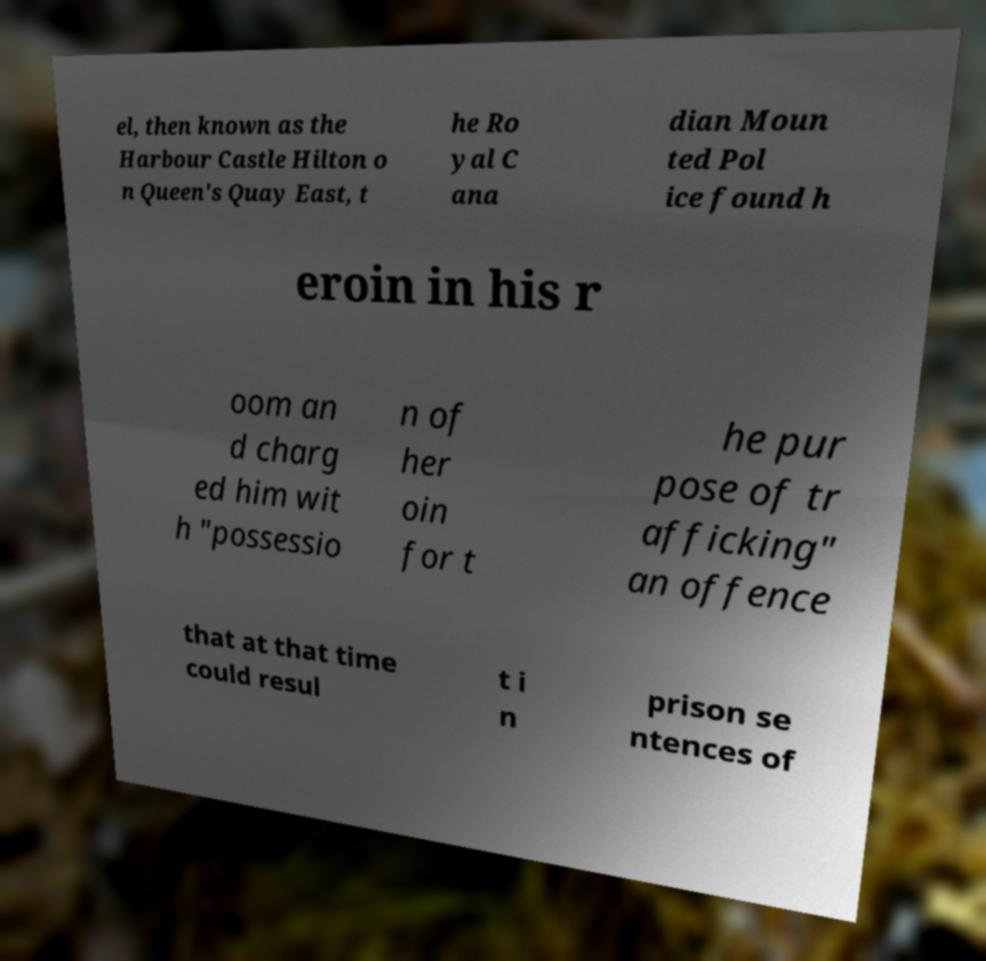There's text embedded in this image that I need extracted. Can you transcribe it verbatim? el, then known as the Harbour Castle Hilton o n Queen's Quay East, t he Ro yal C ana dian Moun ted Pol ice found h eroin in his r oom an d charg ed him wit h "possessio n of her oin for t he pur pose of tr afficking" an offence that at that time could resul t i n prison se ntences of 